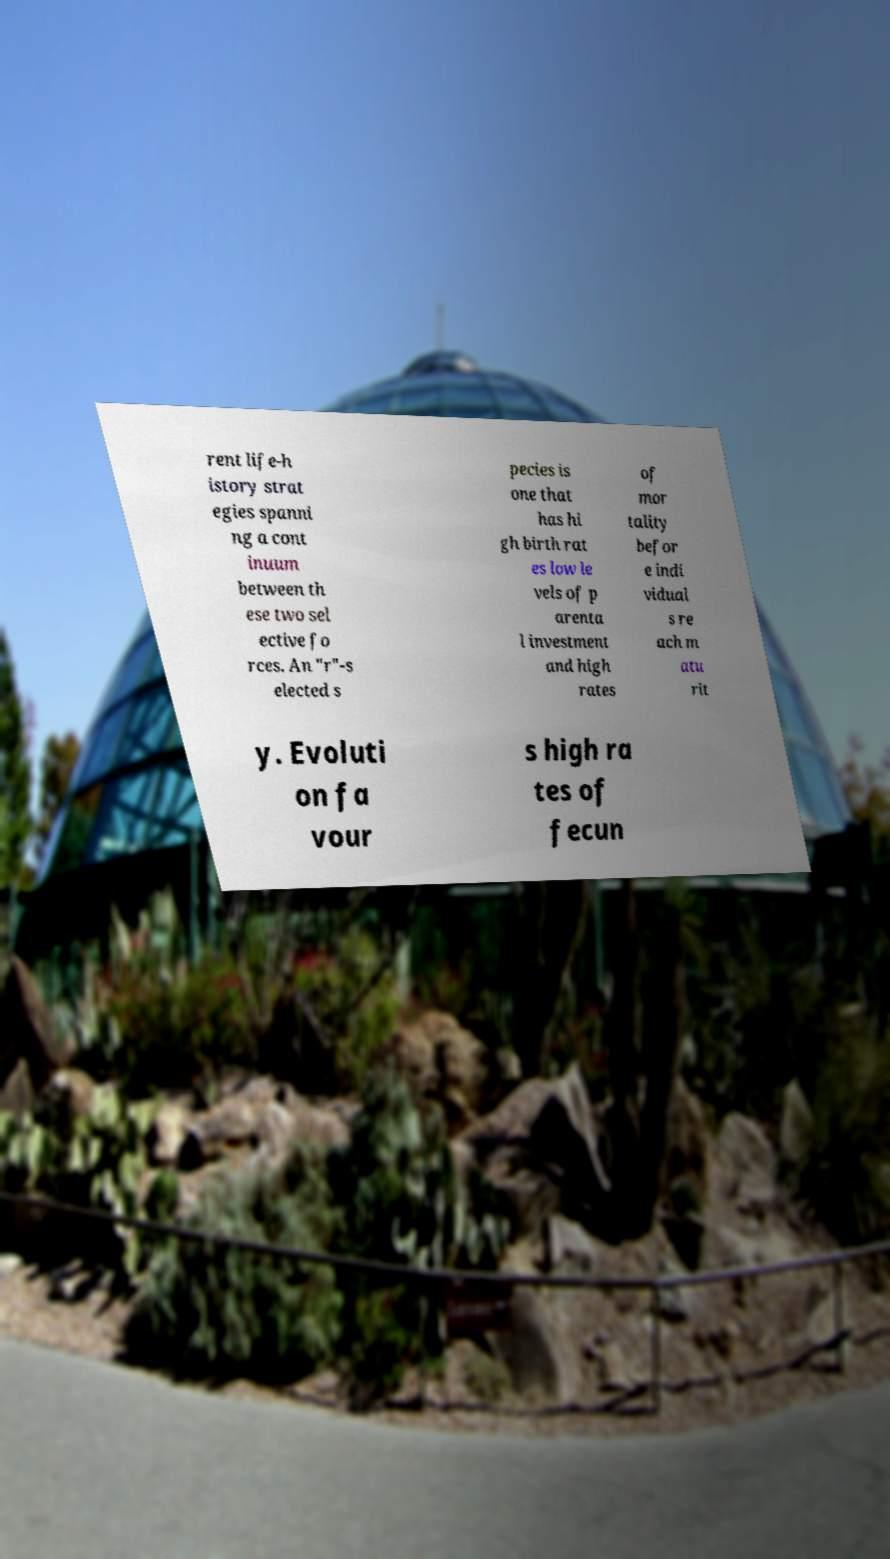Can you read and provide the text displayed in the image?This photo seems to have some interesting text. Can you extract and type it out for me? rent life-h istory strat egies spanni ng a cont inuum between th ese two sel ective fo rces. An "r"-s elected s pecies is one that has hi gh birth rat es low le vels of p arenta l investment and high rates of mor tality befor e indi vidual s re ach m atu rit y. Evoluti on fa vour s high ra tes of fecun 